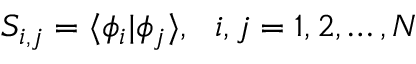<formula> <loc_0><loc_0><loc_500><loc_500>S _ { i , j } = \langle \phi _ { i } | \phi _ { j } \rangle , i , j = 1 , 2 , \dots , N</formula> 